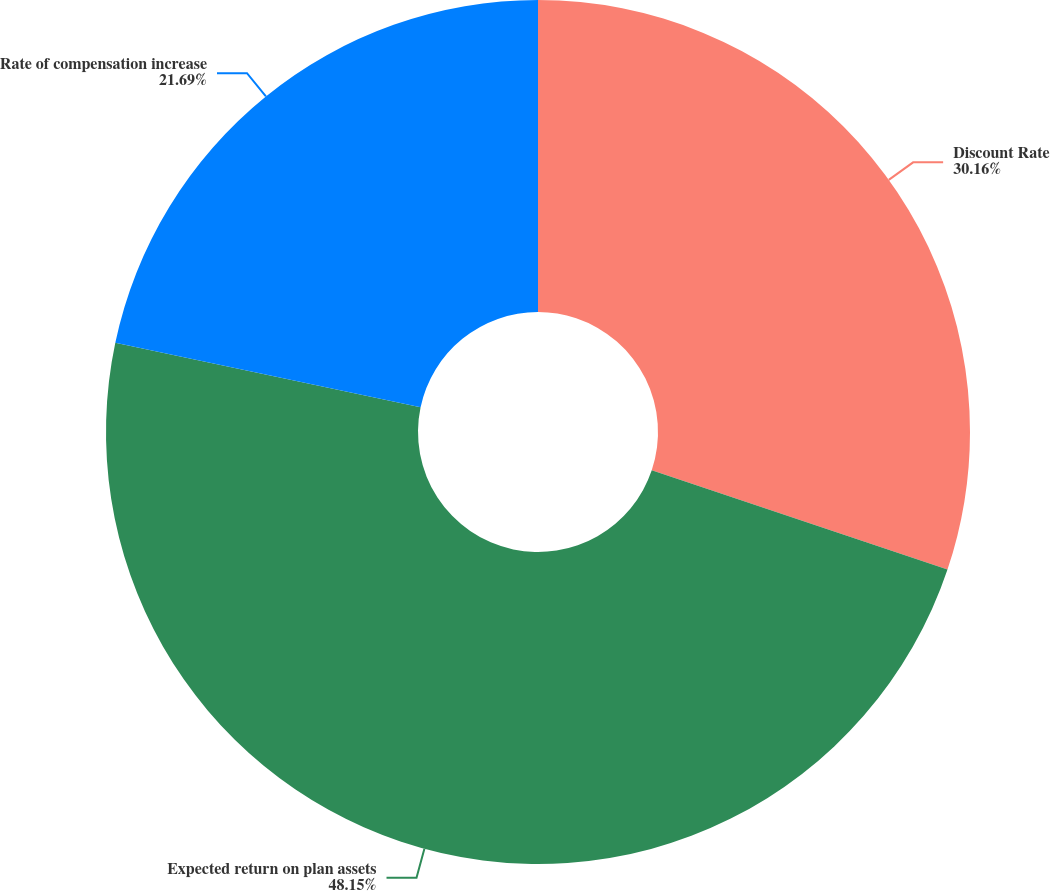Convert chart to OTSL. <chart><loc_0><loc_0><loc_500><loc_500><pie_chart><fcel>Discount Rate<fcel>Expected return on plan assets<fcel>Rate of compensation increase<nl><fcel>30.16%<fcel>48.15%<fcel>21.69%<nl></chart> 